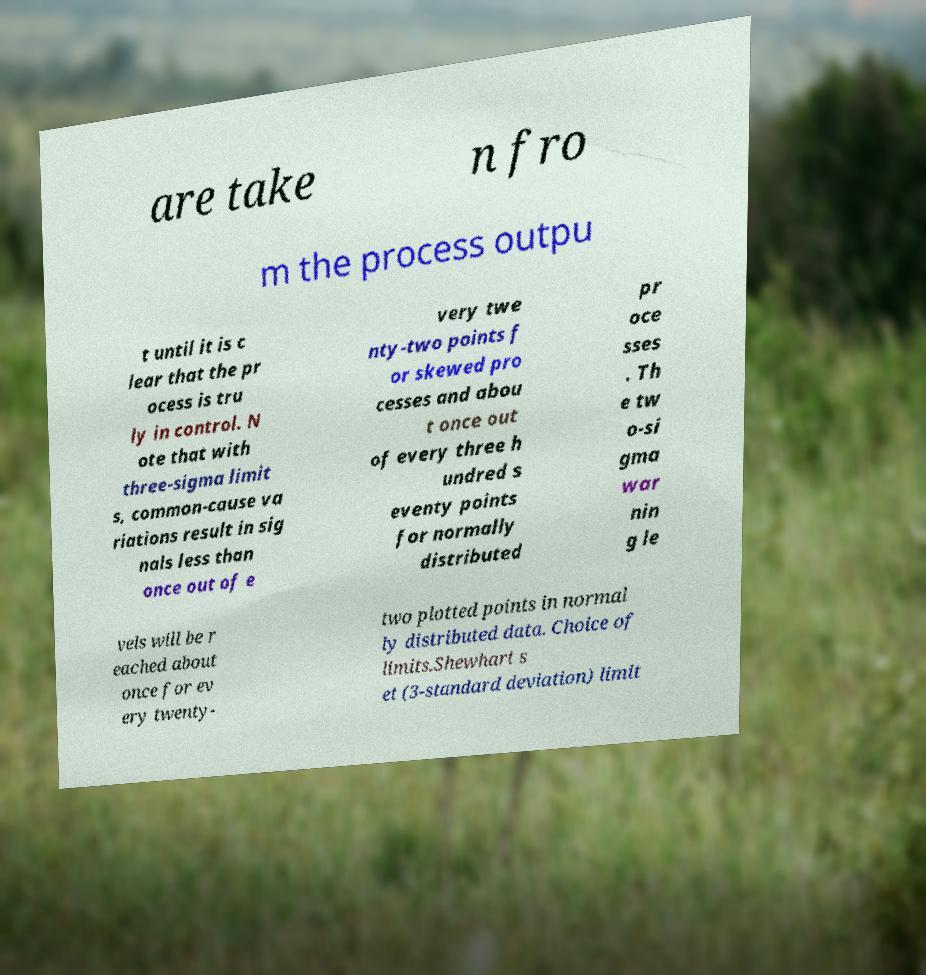For documentation purposes, I need the text within this image transcribed. Could you provide that? are take n fro m the process outpu t until it is c lear that the pr ocess is tru ly in control. N ote that with three-sigma limit s, common-cause va riations result in sig nals less than once out of e very twe nty-two points f or skewed pro cesses and abou t once out of every three h undred s eventy points for normally distributed pr oce sses . Th e tw o-si gma war nin g le vels will be r eached about once for ev ery twenty- two plotted points in normal ly distributed data. Choice of limits.Shewhart s et (3-standard deviation) limit 